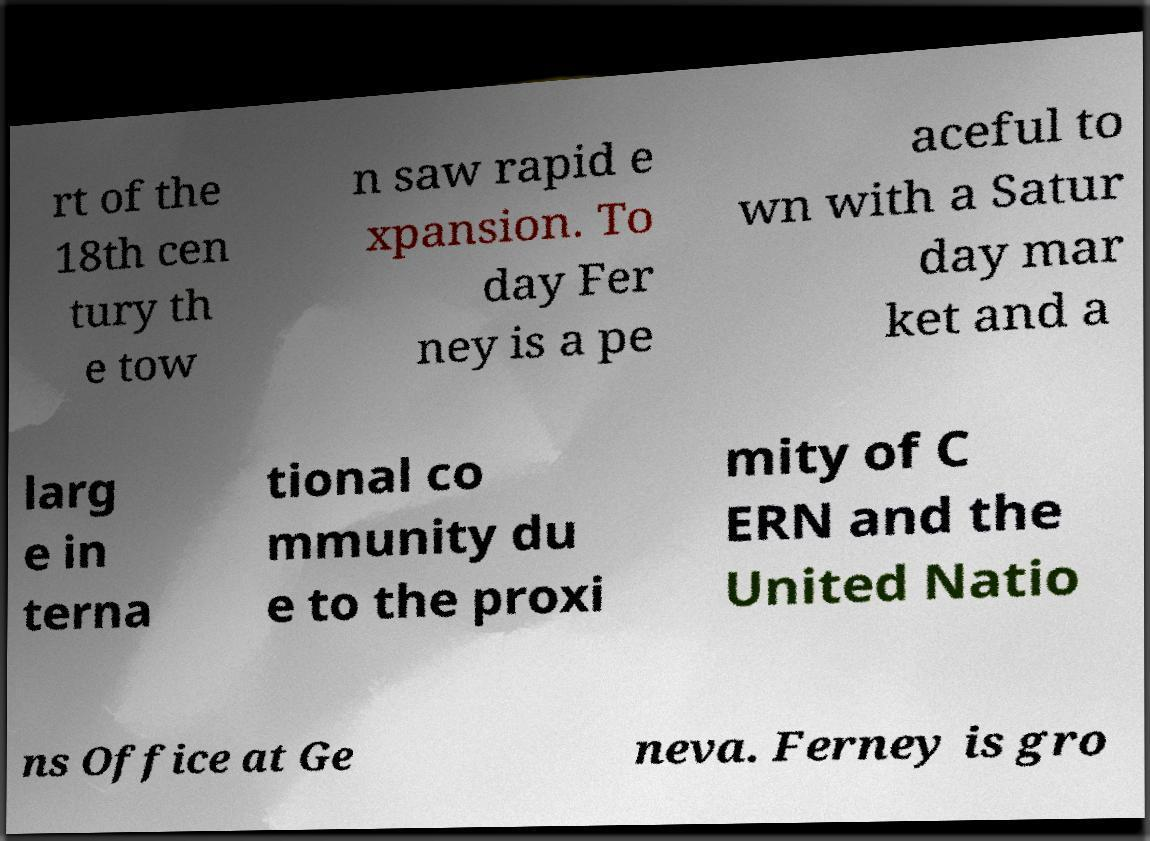For documentation purposes, I need the text within this image transcribed. Could you provide that? rt of the 18th cen tury th e tow n saw rapid e xpansion. To day Fer ney is a pe aceful to wn with a Satur day mar ket and a larg e in terna tional co mmunity du e to the proxi mity of C ERN and the United Natio ns Office at Ge neva. Ferney is gro 